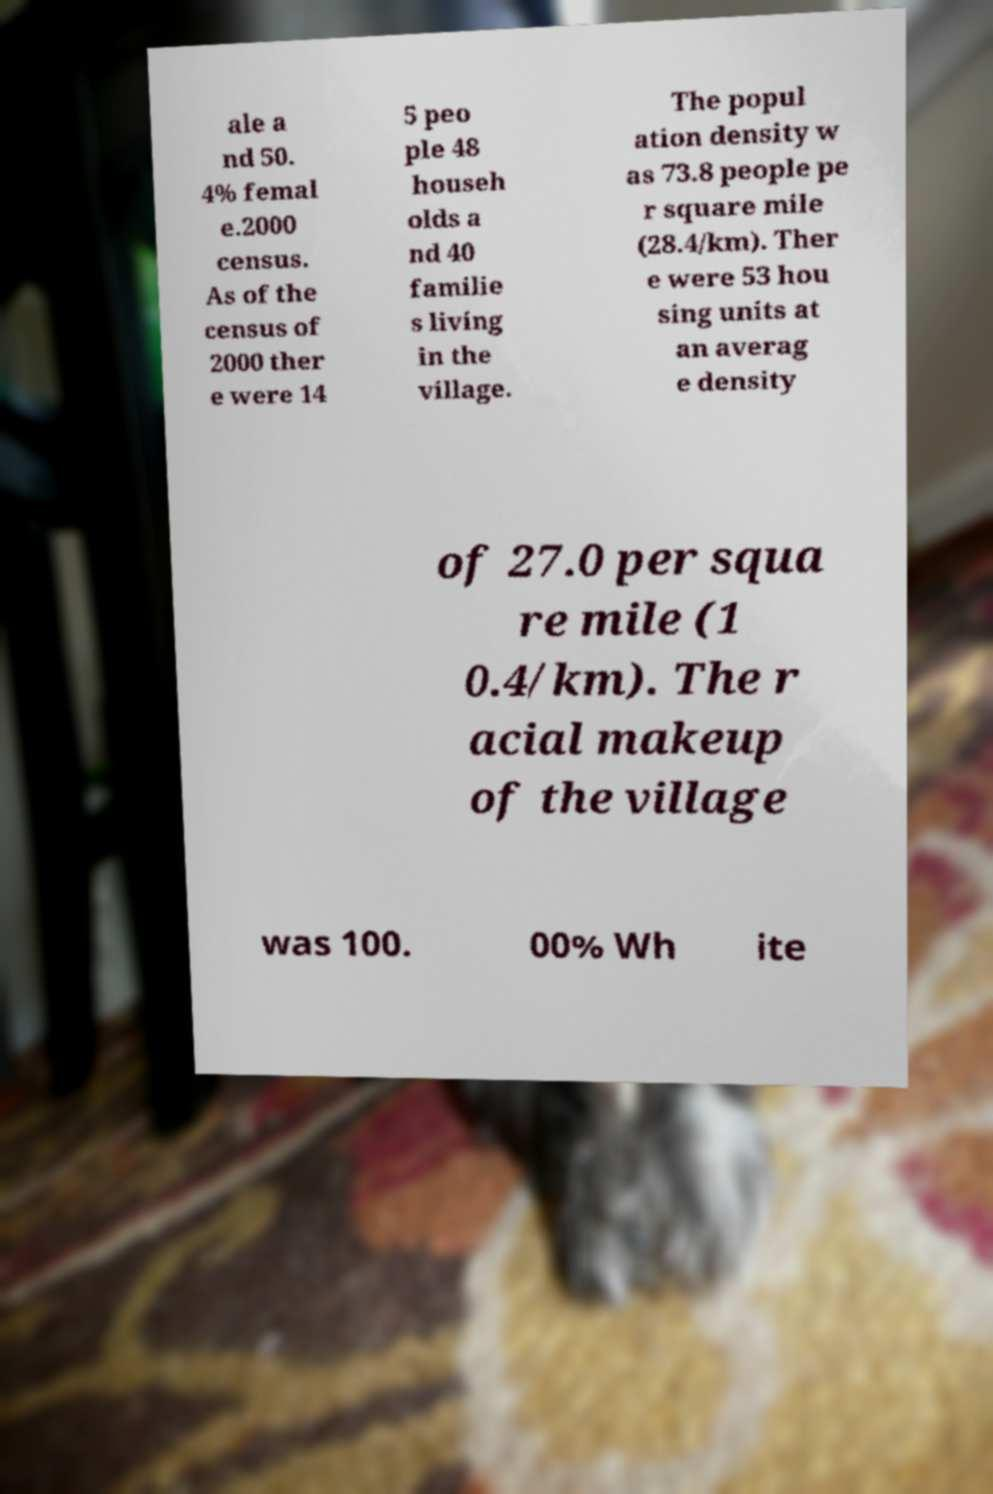Can you read and provide the text displayed in the image?This photo seems to have some interesting text. Can you extract and type it out for me? ale a nd 50. 4% femal e.2000 census. As of the census of 2000 ther e were 14 5 peo ple 48 househ olds a nd 40 familie s living in the village. The popul ation density w as 73.8 people pe r square mile (28.4/km). Ther e were 53 hou sing units at an averag e density of 27.0 per squa re mile (1 0.4/km). The r acial makeup of the village was 100. 00% Wh ite 